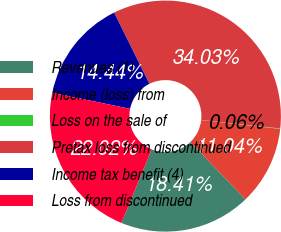Convert chart. <chart><loc_0><loc_0><loc_500><loc_500><pie_chart><fcel>Revenues (1)<fcel>Income (loss) from<fcel>Loss on the sale of<fcel>Pretax loss from discontinued<fcel>Income tax benefit (4)<fcel>Loss from discontinued<nl><fcel>18.41%<fcel>11.04%<fcel>0.06%<fcel>34.03%<fcel>14.44%<fcel>22.02%<nl></chart> 